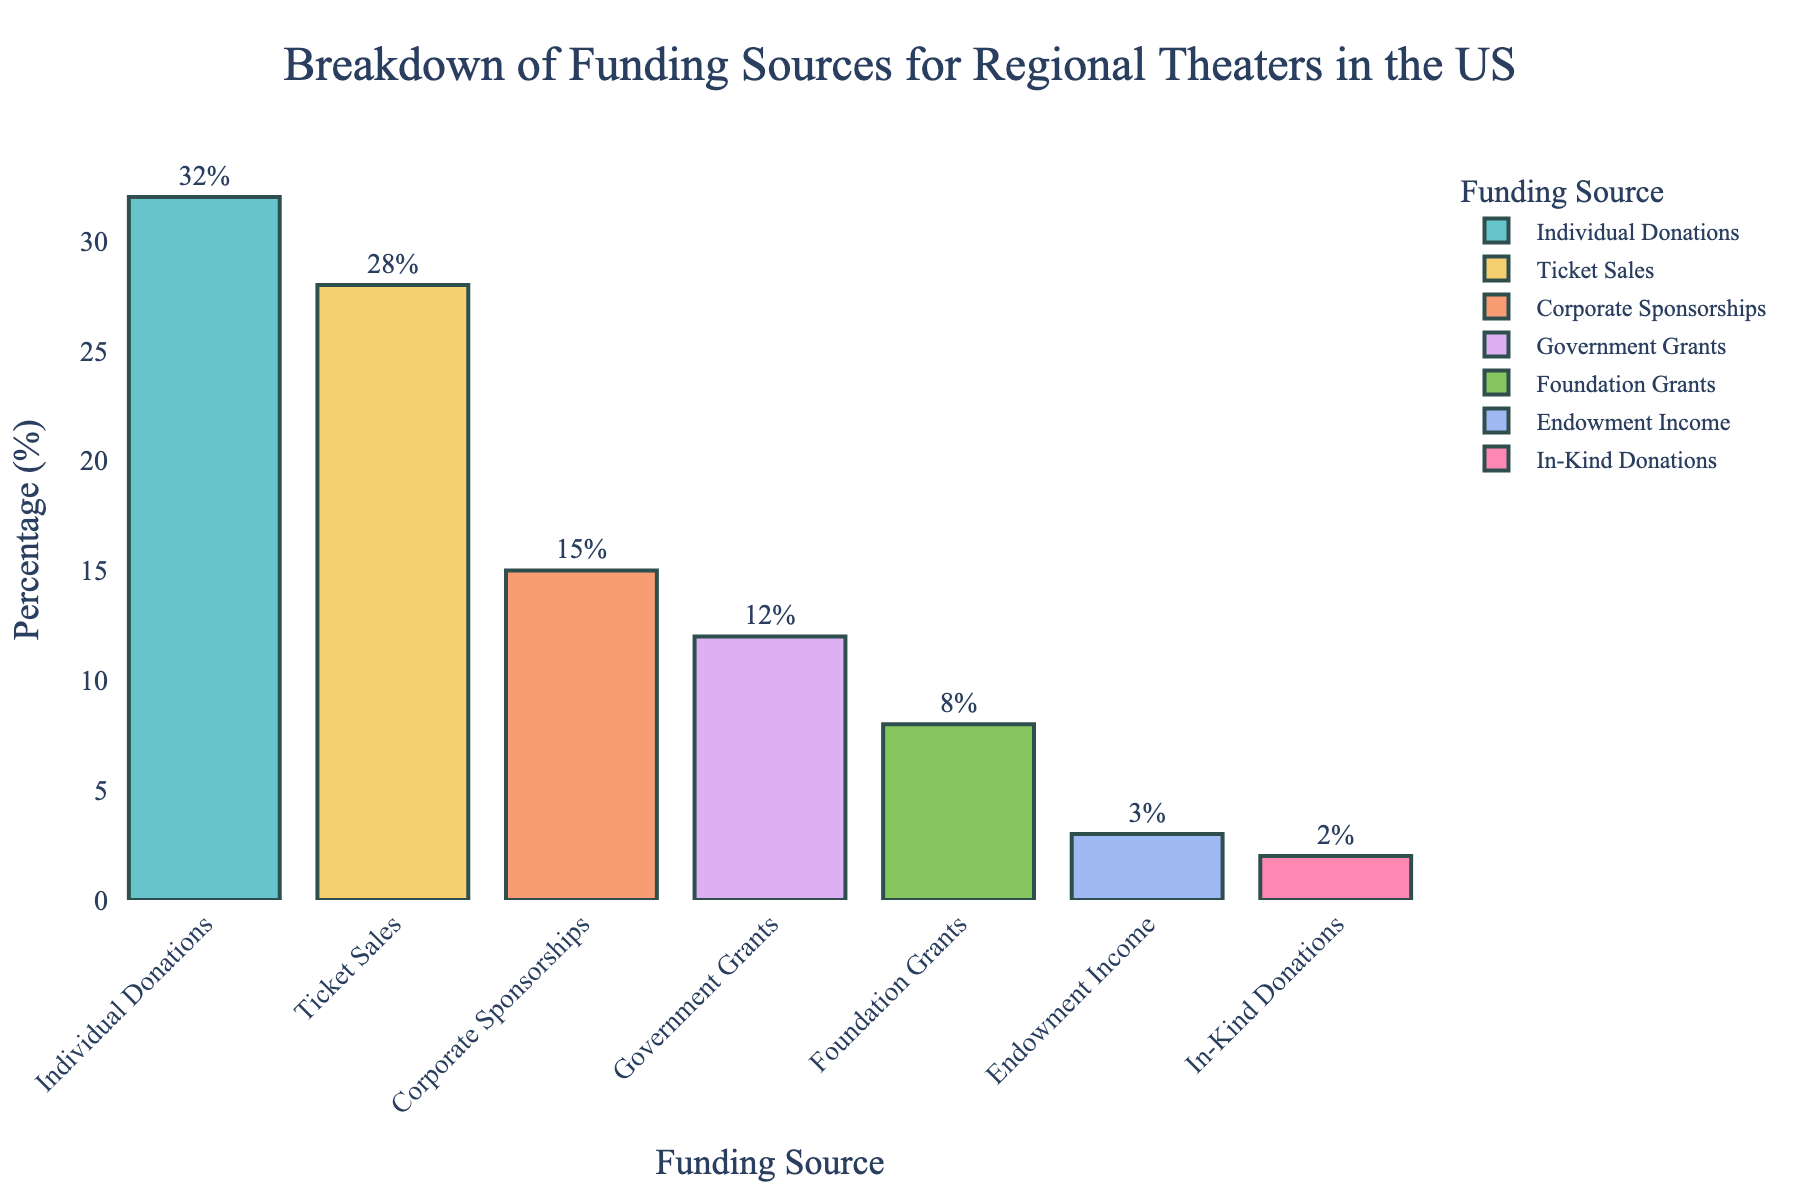What is the most common funding source for regional theaters in the US? The bar for Individual Donations is the tallest at 32%, indicating it is the most common funding source.
Answer: Individual Donations Which funding source contributes less than 10% of the total funding? The bars for Foundation Grants, Endowment Income, and In-Kind Donations are all under 10%, specifically 8%, 3%, and 2% respectively.
Answer: Foundation Grants, Endowment Income, In-Kind Donations What is the combined percentage of funding from Corporate Sponsorships and Government Grants? The percentage for Corporate Sponsorships is 15%, and for Government Grants, it is 12%. Adding these together: 15% + 12% = 27%
Answer: 27% How do Individual Donations and Ticket Sales compare in terms of their percentage contribution? The bar for Individual Donations is at 32%, and the bar for Ticket Sales is at 28%. Individual Donations contribute 4% more than Ticket Sales.
Answer: Individual Donations contributes 4% more Which funding source has the smallest contribution to regional theaters? The bar for In-Kind Donations is the shortest at 2%.
Answer: In-Kind Donations Rank the funding sources from highest to lowest contribution. Observing the height of the bars from tallest to shortest: 1. Individual Donations 2. Ticket Sales 3. Corporate Sponsorships 4. Government Grants 5. Foundation Grants 6. Endowment Income 7. In-Kind Donations
Answer: Individual Donations, Ticket Sales, Corporate Sponsorships, Government Grants, Foundation Grants, Endowment Income, In-Kind Donations Is the sum of the percentages from Foundation Grants and Endowment Income greater than Ticket Sales? The percentage for Foundation Grants is 8%, and for Endowment Income, it is 3%. Adding these gives 11%. Ticket Sales contribute 28%, which is higher than the combined 11%.
Answer: No Do Corporate Sponsorships and Government Grants together contribute more than Individual Donations alone? The percentage for Corporate Sponsorships is 15%, and for Government Grants, it is 12%. Together, they make up 27%, which is less than Individual Donations at 32%.
Answer: No How much more does Individual Donations contribute compared to Endowment Income? Individual Donations contribute 32%, while Endowment Income contributes 3%. The difference is 32% - 3% = 29%.
Answer: 29% 